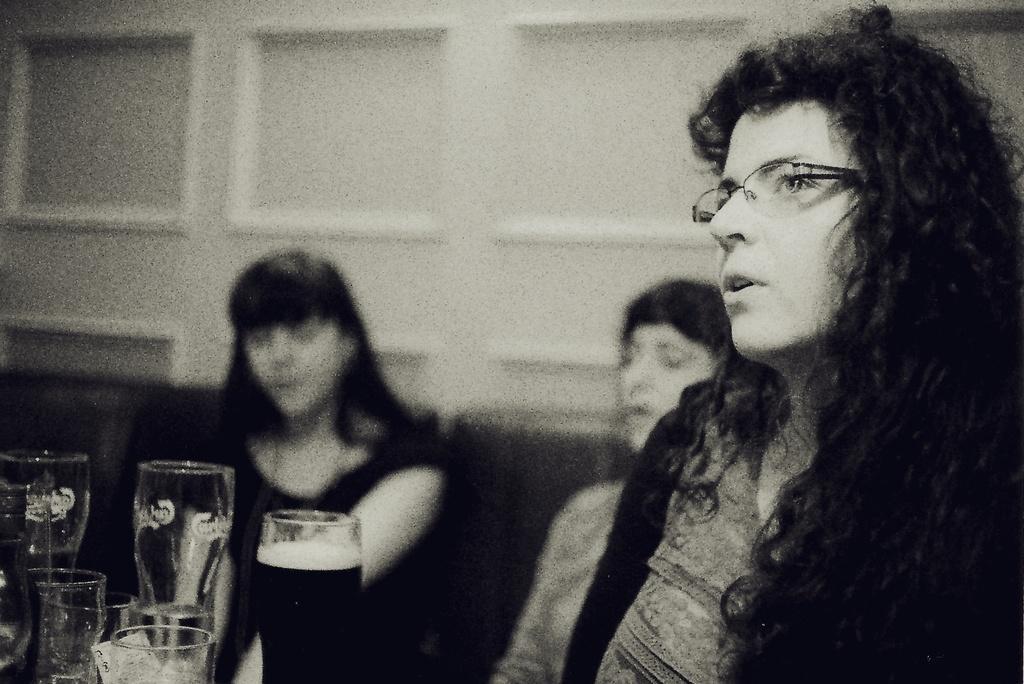Can you describe this image briefly? In this black and white picture there is a woman wearing spectacles. Left side there are glasses. Behind there are people. Background there is a wall. 